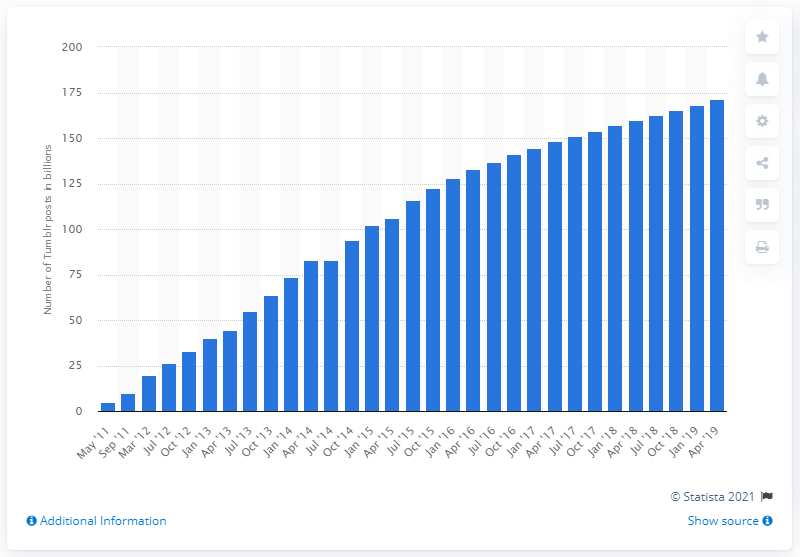List a handful of essential elements in this visual. In the previous year, Tumblr had a total of 160 posts. Tumblr posted a total of 171.5 posts between May 2011 and April 2019. 